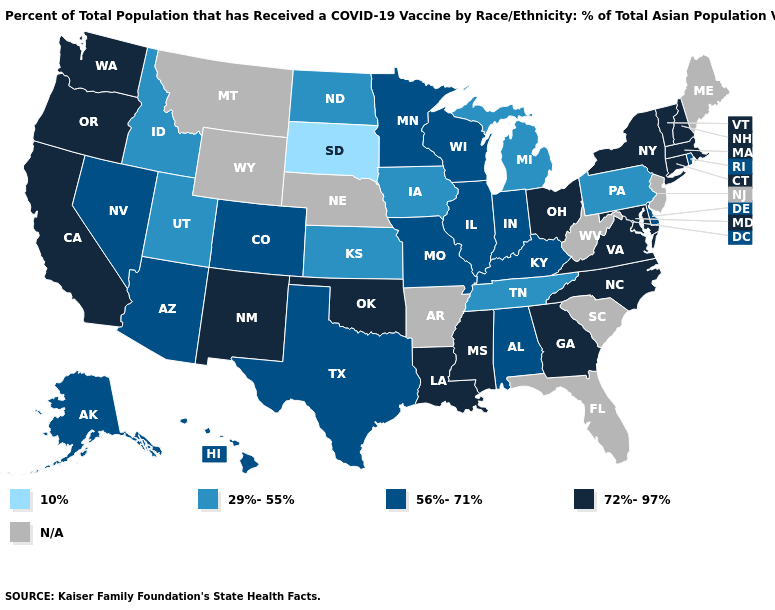Does Oklahoma have the highest value in the USA?
Be succinct. Yes. Which states have the highest value in the USA?
Give a very brief answer. California, Connecticut, Georgia, Louisiana, Maryland, Massachusetts, Mississippi, New Hampshire, New Mexico, New York, North Carolina, Ohio, Oklahoma, Oregon, Vermont, Virginia, Washington. Name the states that have a value in the range 29%-55%?
Quick response, please. Idaho, Iowa, Kansas, Michigan, North Dakota, Pennsylvania, Tennessee, Utah. Name the states that have a value in the range 56%-71%?
Be succinct. Alabama, Alaska, Arizona, Colorado, Delaware, Hawaii, Illinois, Indiana, Kentucky, Minnesota, Missouri, Nevada, Rhode Island, Texas, Wisconsin. What is the value of Florida?
Quick response, please. N/A. Does Massachusetts have the lowest value in the Northeast?
Be succinct. No. Name the states that have a value in the range N/A?
Give a very brief answer. Arkansas, Florida, Maine, Montana, Nebraska, New Jersey, South Carolina, West Virginia, Wyoming. What is the lowest value in states that border Texas?
Write a very short answer. 72%-97%. Which states have the lowest value in the West?
Answer briefly. Idaho, Utah. What is the value of Minnesota?
Quick response, please. 56%-71%. Name the states that have a value in the range 29%-55%?
Quick response, please. Idaho, Iowa, Kansas, Michigan, North Dakota, Pennsylvania, Tennessee, Utah. Name the states that have a value in the range 29%-55%?
Short answer required. Idaho, Iowa, Kansas, Michigan, North Dakota, Pennsylvania, Tennessee, Utah. What is the value of Rhode Island?
Be succinct. 56%-71%. Name the states that have a value in the range 72%-97%?
Quick response, please. California, Connecticut, Georgia, Louisiana, Maryland, Massachusetts, Mississippi, New Hampshire, New Mexico, New York, North Carolina, Ohio, Oklahoma, Oregon, Vermont, Virginia, Washington. 